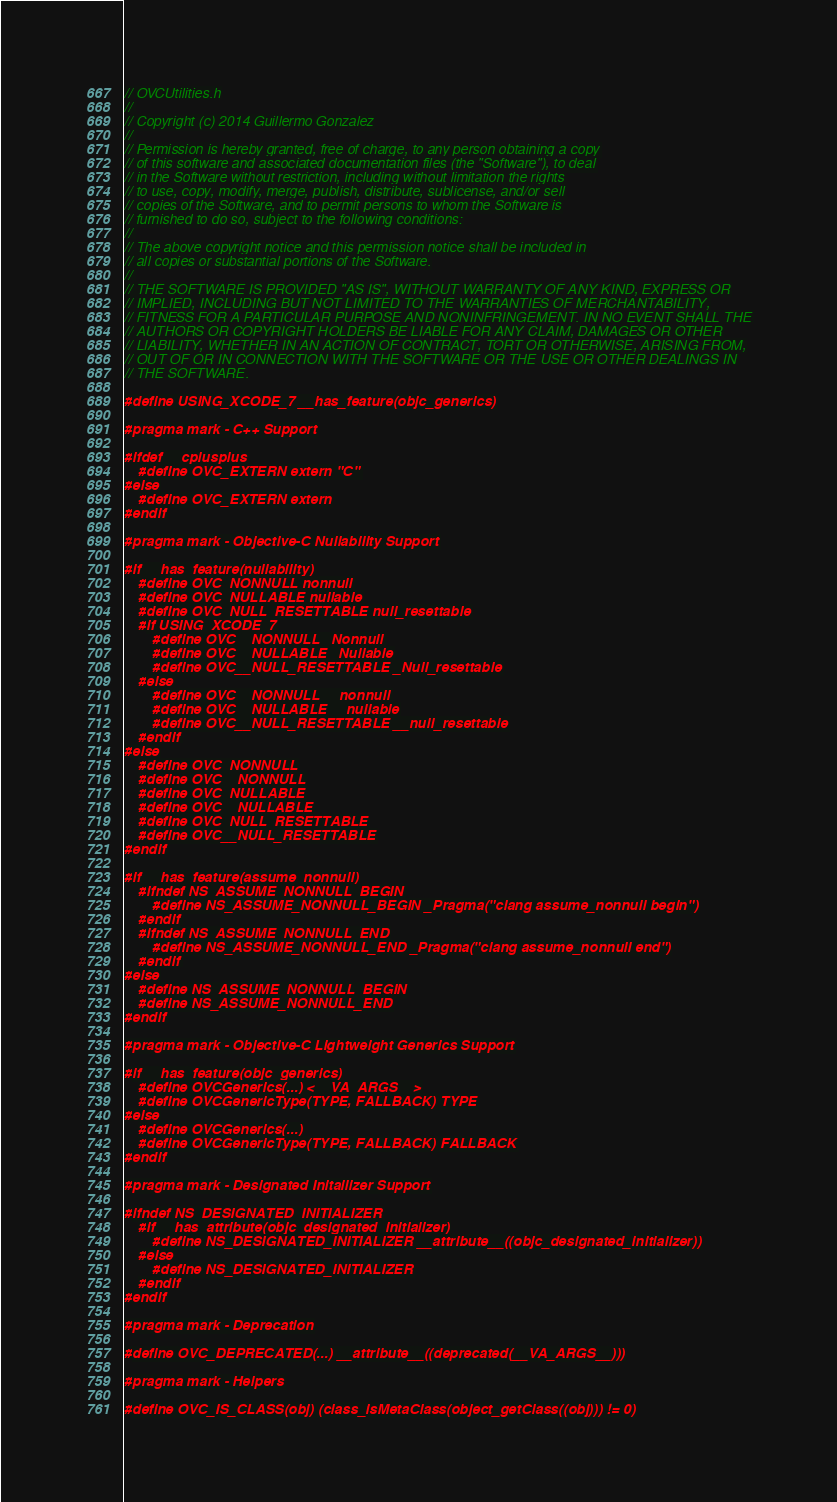<code> <loc_0><loc_0><loc_500><loc_500><_C_>// OVCUtilities.h
//
// Copyright (c) 2014 Guillermo Gonzalez
//
// Permission is hereby granted, free of charge, to any person obtaining a copy
// of this software and associated documentation files (the "Software"), to deal
// in the Software without restriction, including without limitation the rights
// to use, copy, modify, merge, publish, distribute, sublicense, and/or sell
// copies of the Software, and to permit persons to whom the Software is
// furnished to do so, subject to the following conditions:
//
// The above copyright notice and this permission notice shall be included in
// all copies or substantial portions of the Software.
//
// THE SOFTWARE IS PROVIDED "AS IS", WITHOUT WARRANTY OF ANY KIND, EXPRESS OR
// IMPLIED, INCLUDING BUT NOT LIMITED TO THE WARRANTIES OF MERCHANTABILITY,
// FITNESS FOR A PARTICULAR PURPOSE AND NONINFRINGEMENT. IN NO EVENT SHALL THE
// AUTHORS OR COPYRIGHT HOLDERS BE LIABLE FOR ANY CLAIM, DAMAGES OR OTHER
// LIABILITY, WHETHER IN AN ACTION OF CONTRACT, TORT OR OTHERWISE, ARISING FROM,
// OUT OF OR IN CONNECTION WITH THE SOFTWARE OR THE USE OR OTHER DEALINGS IN
// THE SOFTWARE.

#define USING_XCODE_7 __has_feature(objc_generics)

#pragma mark - C++ Support

#ifdef __cplusplus
    #define OVC_EXTERN extern "C"
#else
    #define OVC_EXTERN extern
#endif

#pragma mark - Objective-C Nullability Support

#if __has_feature(nullability)
    #define OVC_NONNULL nonnull
    #define OVC_NULLABLE nullable
    #define OVC_NULL_RESETTABLE null_resettable
    #if USING_XCODE_7
        #define OVC__NONNULL _Nonnull
        #define OVC__NULLABLE _Nullable
        #define OVC__NULL_RESETTABLE _Null_resettable
    #else
        #define OVC__NONNULL __nonnull
        #define OVC__NULLABLE __nullable
        #define OVC__NULL_RESETTABLE __null_resettable
    #endif
#else
    #define OVC_NONNULL
    #define OVC__NONNULL
    #define OVC_NULLABLE
    #define OVC__NULLABLE
    #define OVC_NULL_RESETTABLE
    #define OVC__NULL_RESETTABLE
#endif

#if __has_feature(assume_nonnull)
    #ifndef NS_ASSUME_NONNULL_BEGIN
        #define NS_ASSUME_NONNULL_BEGIN _Pragma("clang assume_nonnull begin")
    #endif
    #ifndef NS_ASSUME_NONNULL_END
        #define NS_ASSUME_NONNULL_END _Pragma("clang assume_nonnull end")
    #endif
#else
    #define NS_ASSUME_NONNULL_BEGIN
    #define NS_ASSUME_NONNULL_END
#endif

#pragma mark - Objective-C Lightweight Generics Support

#if __has_feature(objc_generics)
    #define OVCGenerics(...) <__VA_ARGS__>
    #define OVCGenericType(TYPE, FALLBACK) TYPE
#else
    #define OVCGenerics(...)
    #define OVCGenericType(TYPE, FALLBACK) FALLBACK
#endif

#pragma mark - Designated Initailizer Support

#ifndef NS_DESIGNATED_INITIALIZER
    #if __has_attribute(objc_designated_initializer)
        #define NS_DESIGNATED_INITIALIZER __attribute__((objc_designated_initializer))
    #else
        #define NS_DESIGNATED_INITIALIZER
    #endif
#endif

#pragma mark - Deprecation

#define OVC_DEPRECATED(...) __attribute__((deprecated(__VA_ARGS__)))

#pragma mark - Helpers

#define OVC_IS_CLASS(obj) (class_isMetaClass(object_getClass((obj))) != 0)
</code> 